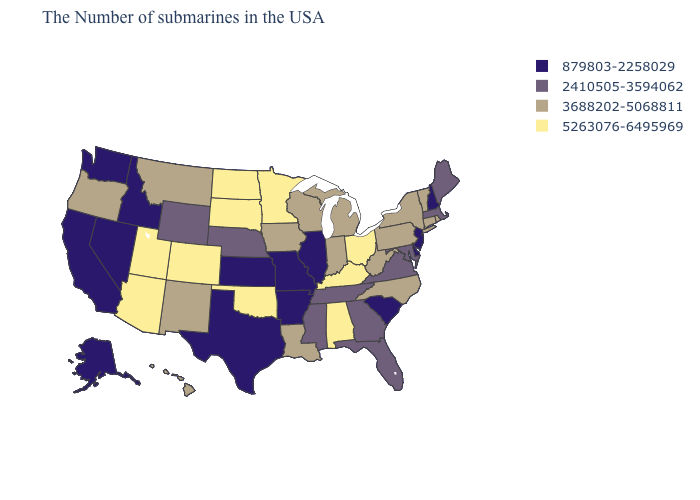Does New Mexico have a lower value than Hawaii?
Write a very short answer. No. Does Utah have the lowest value in the West?
Be succinct. No. Among the states that border Kentucky , which have the lowest value?
Short answer required. Illinois, Missouri. Among the states that border Arizona , which have the lowest value?
Answer briefly. Nevada, California. Does the map have missing data?
Keep it brief. No. Does the map have missing data?
Concise answer only. No. Does Arizona have the same value as Pennsylvania?
Be succinct. No. What is the highest value in the USA?
Answer briefly. 5263076-6495969. What is the value of Oklahoma?
Answer briefly. 5263076-6495969. Name the states that have a value in the range 5263076-6495969?
Answer briefly. Ohio, Kentucky, Alabama, Minnesota, Oklahoma, South Dakota, North Dakota, Colorado, Utah, Arizona. Among the states that border Texas , which have the highest value?
Quick response, please. Oklahoma. What is the value of West Virginia?
Keep it brief. 3688202-5068811. Which states have the lowest value in the Northeast?
Answer briefly. New Hampshire, New Jersey. Is the legend a continuous bar?
Short answer required. No. 